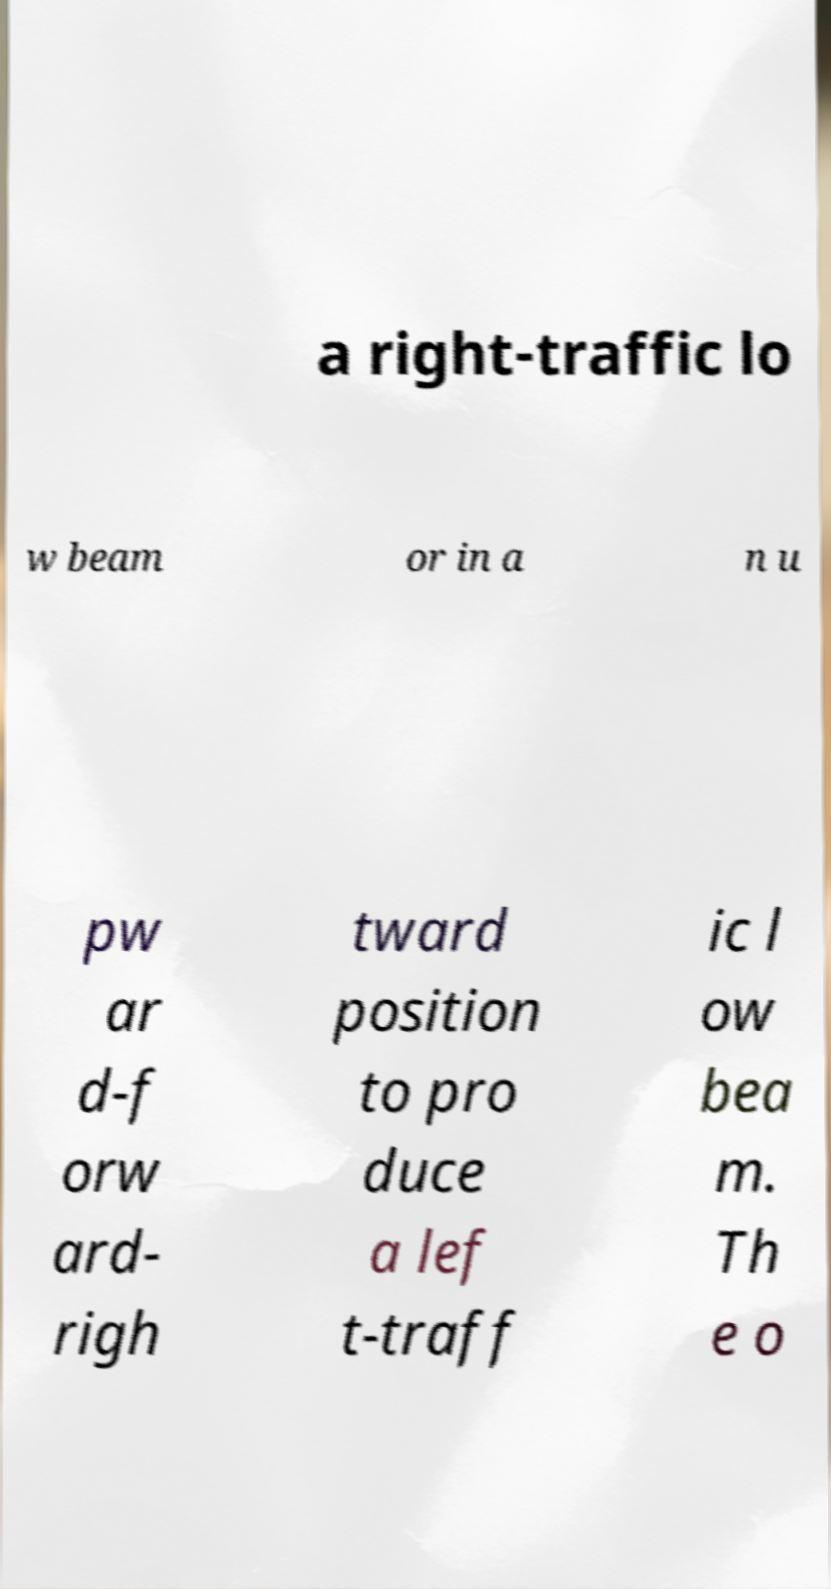I need the written content from this picture converted into text. Can you do that? a right-traffic lo w beam or in a n u pw ar d-f orw ard- righ tward position to pro duce a lef t-traff ic l ow bea m. Th e o 